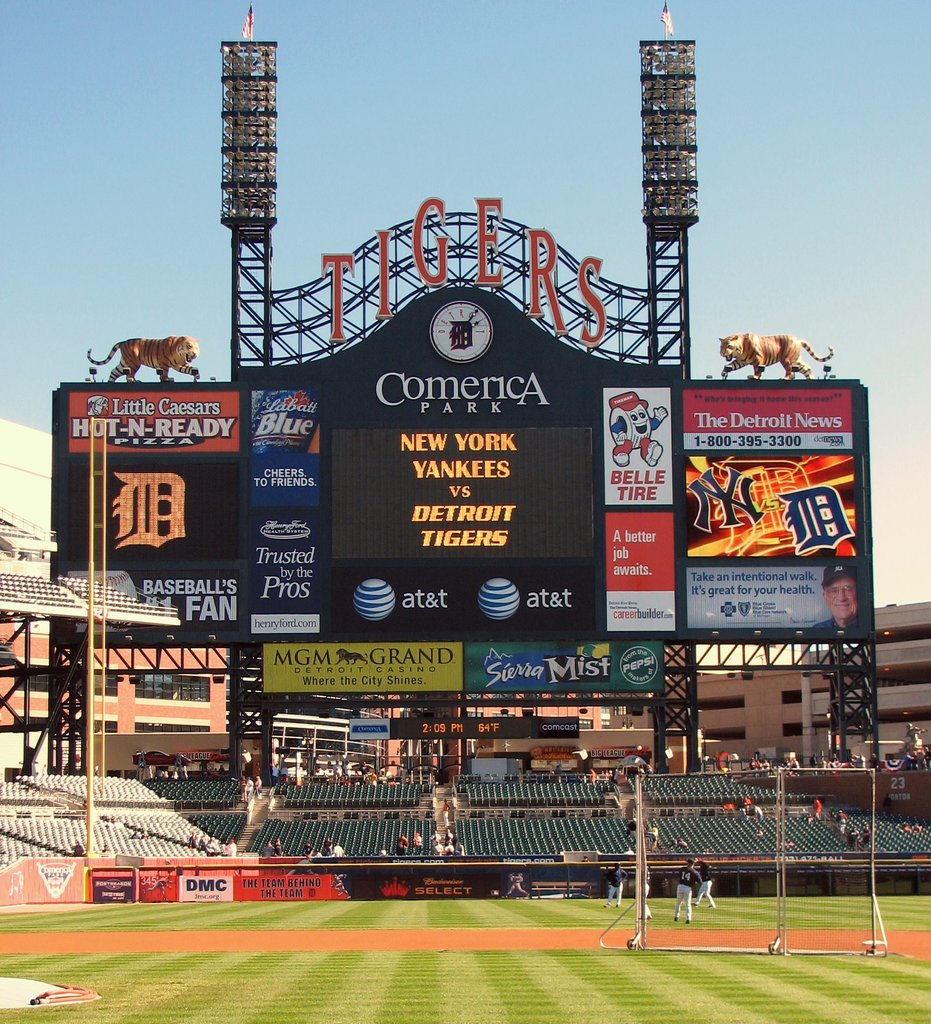What details can you tell me about the setting of this image? This image shows the interior of Comerica Park, home of the Detroit Tigers, featuring a large scoreboard displaying an upcoming game against the New York Yankees. The board is filled with advertisements from various sponsors such as Little Caesars and AT&T, along with mascot and team logos. 